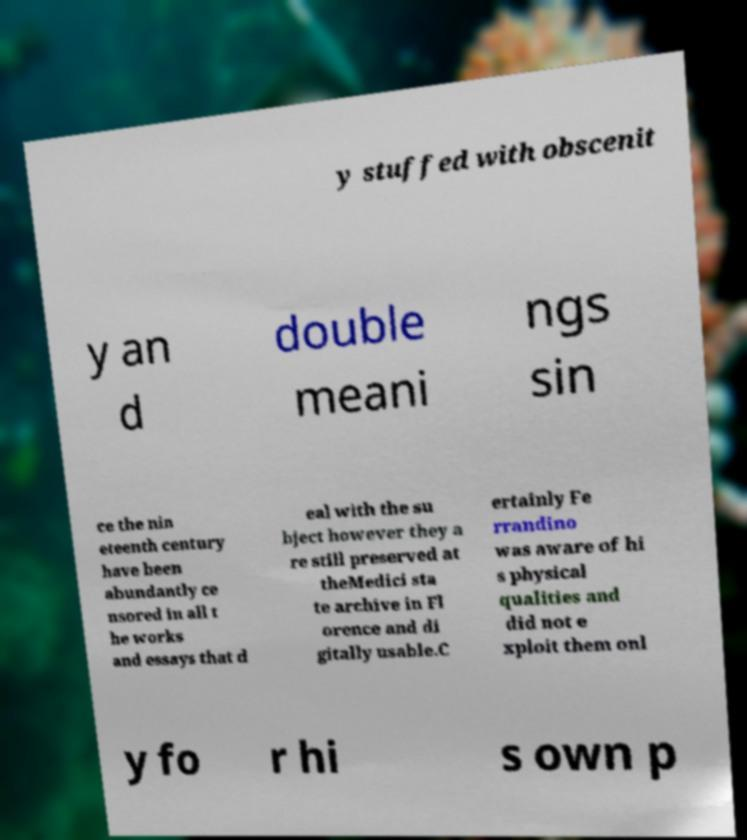Can you read and provide the text displayed in the image?This photo seems to have some interesting text. Can you extract and type it out for me? y stuffed with obscenit y an d double meani ngs sin ce the nin eteenth century have been abundantly ce nsored in all t he works and essays that d eal with the su bject however they a re still preserved at theMedici sta te archive in Fl orence and di gitally usable.C ertainly Fe rrandino was aware of hi s physical qualities and did not e xploit them onl y fo r hi s own p 